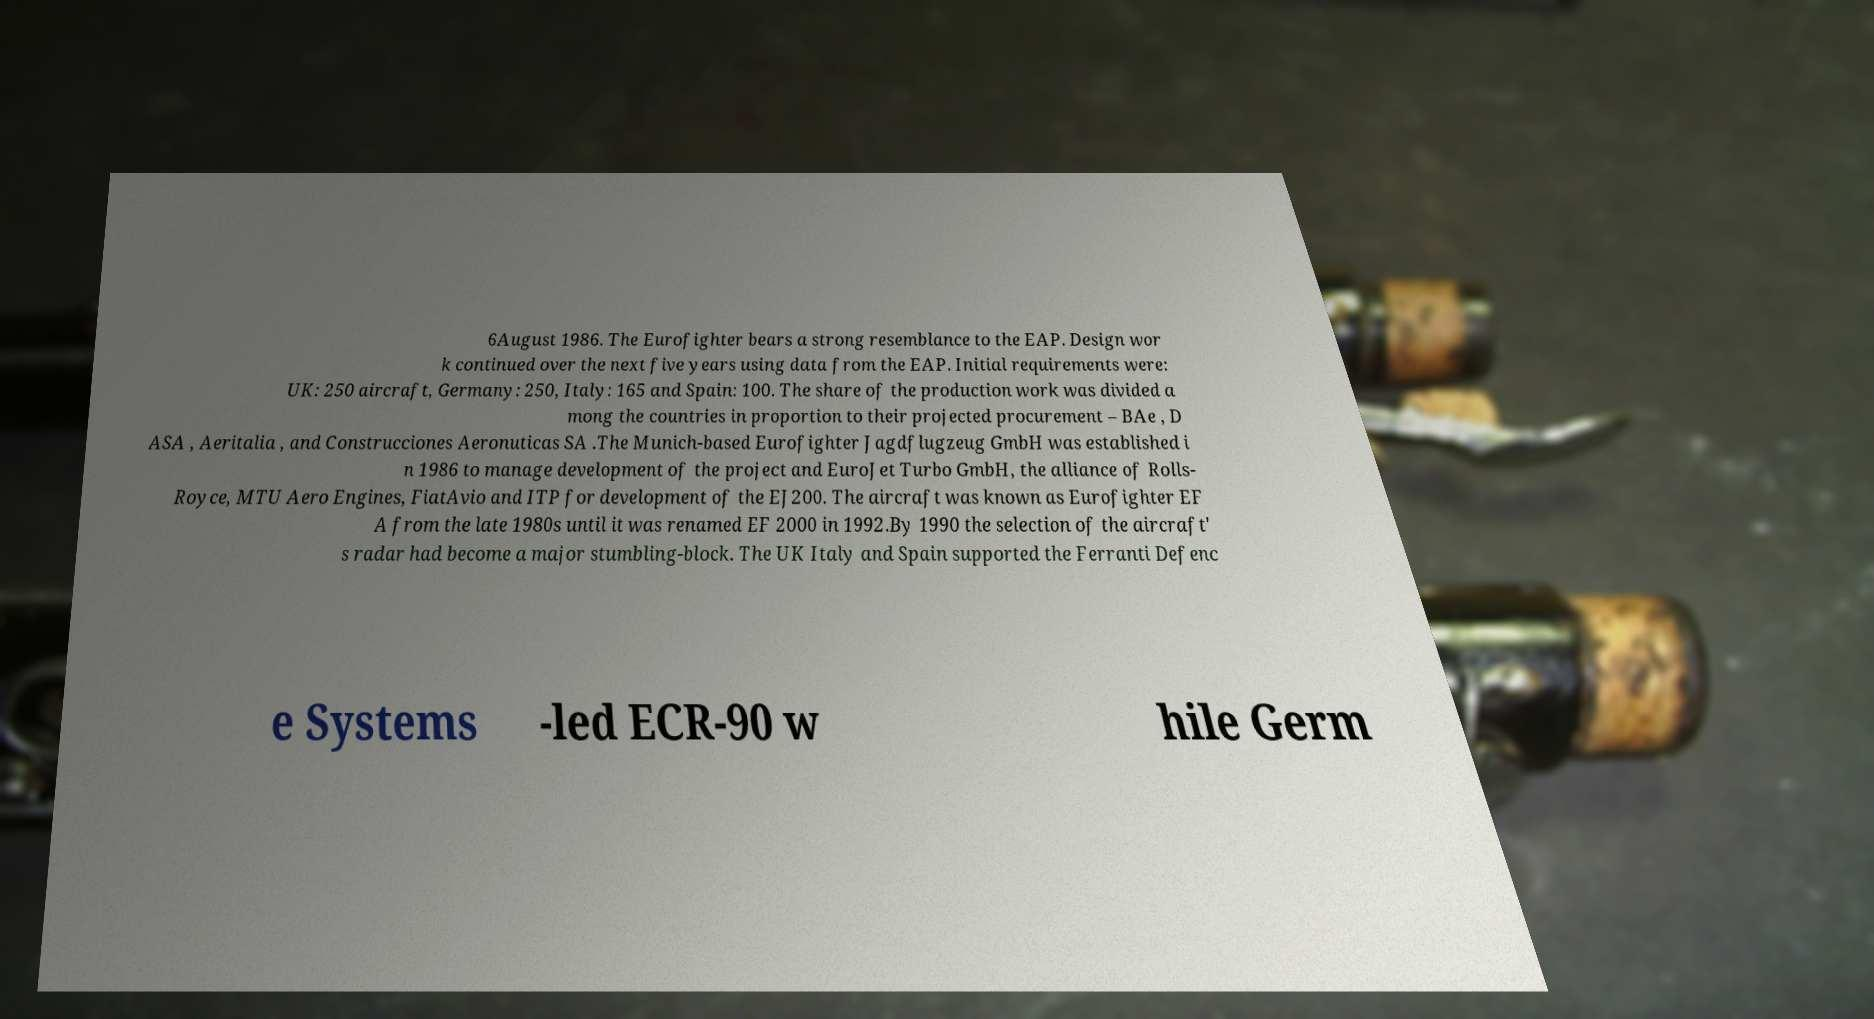Could you extract and type out the text from this image? 6August 1986. The Eurofighter bears a strong resemblance to the EAP. Design wor k continued over the next five years using data from the EAP. Initial requirements were: UK: 250 aircraft, Germany: 250, Italy: 165 and Spain: 100. The share of the production work was divided a mong the countries in proportion to their projected procurement – BAe , D ASA , Aeritalia , and Construcciones Aeronuticas SA .The Munich-based Eurofighter Jagdflugzeug GmbH was established i n 1986 to manage development of the project and EuroJet Turbo GmbH, the alliance of Rolls- Royce, MTU Aero Engines, FiatAvio and ITP for development of the EJ200. The aircraft was known as Eurofighter EF A from the late 1980s until it was renamed EF 2000 in 1992.By 1990 the selection of the aircraft' s radar had become a major stumbling-block. The UK Italy and Spain supported the Ferranti Defenc e Systems -led ECR-90 w hile Germ 